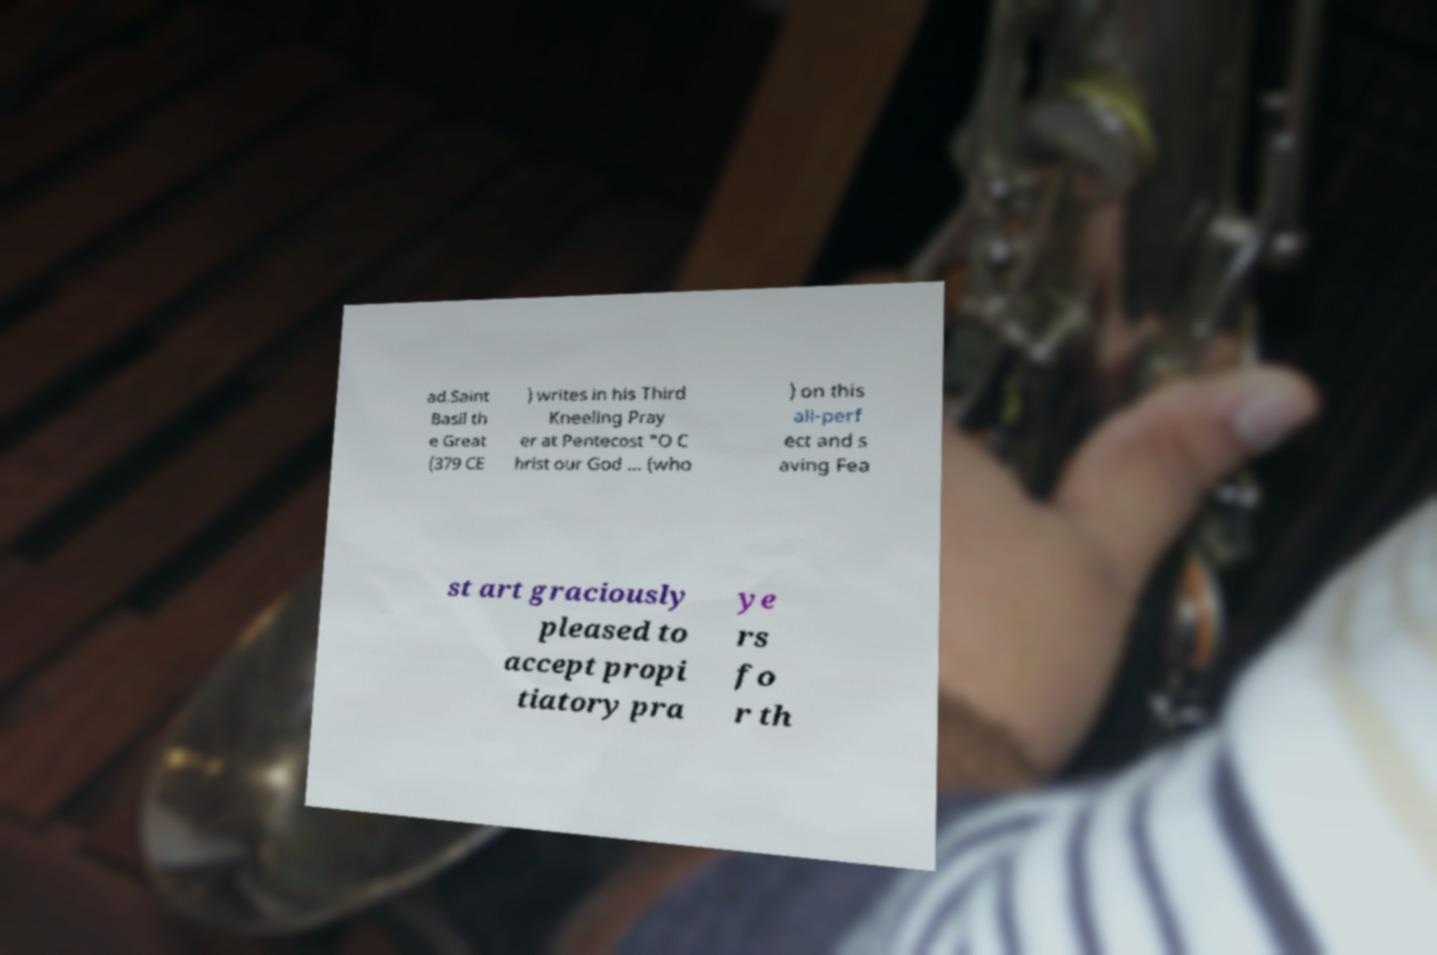Please identify and transcribe the text found in this image. ad.Saint Basil th e Great (379 CE ) writes in his Third Kneeling Pray er at Pentecost "O C hrist our God ... (who ) on this all-perf ect and s aving Fea st art graciously pleased to accept propi tiatory pra ye rs fo r th 